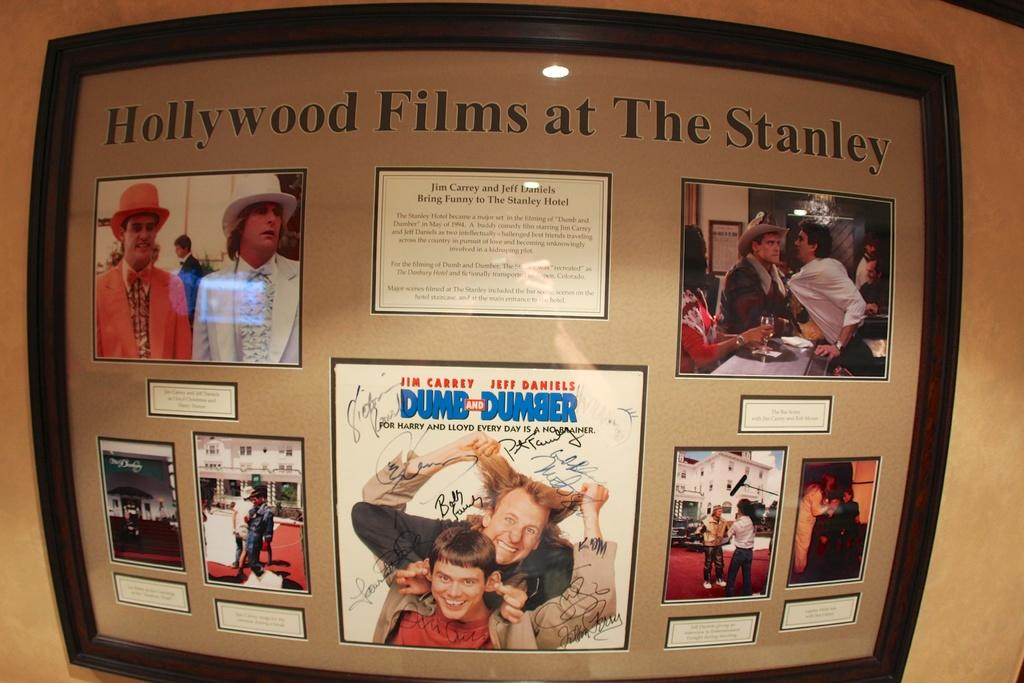<image>
Share a concise interpretation of the image provided. A framed display titled Hollywood Films at The Stanley. 